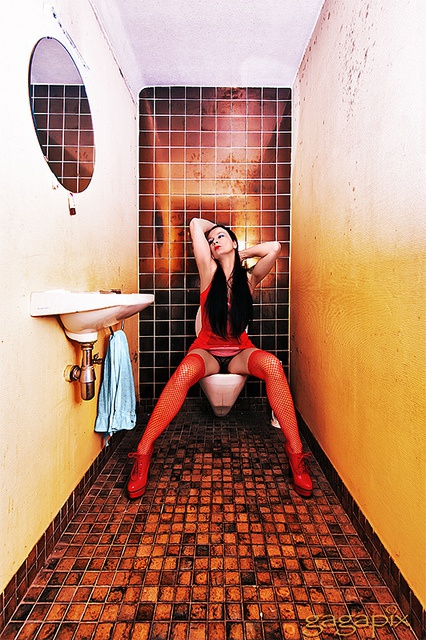Describe the objects in this image and their specific colors. I can see people in white, black, red, brown, and salmon tones, sink in white, tan, and brown tones, and toilet in white, lightpink, brown, lightgray, and maroon tones in this image. 